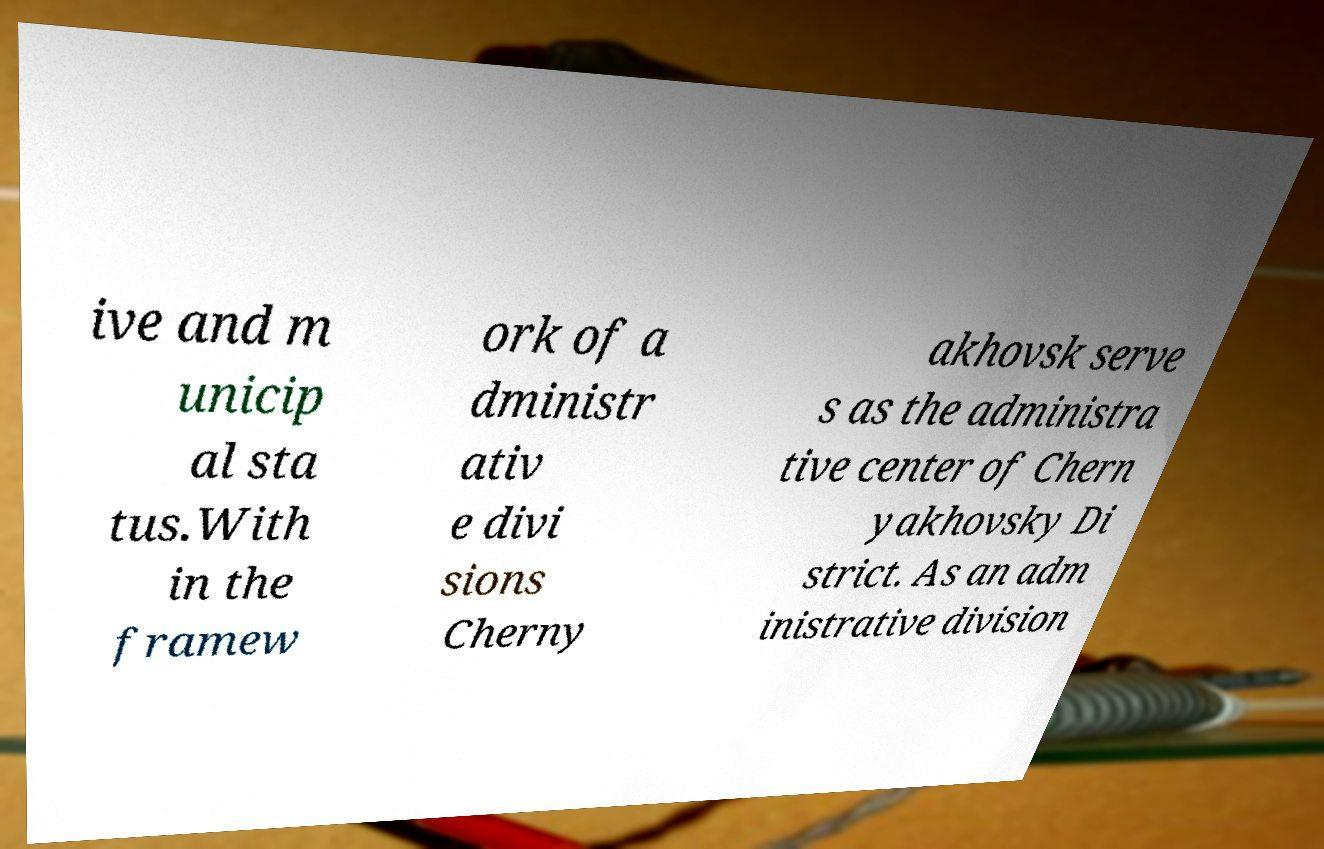Could you extract and type out the text from this image? ive and m unicip al sta tus.With in the framew ork of a dministr ativ e divi sions Cherny akhovsk serve s as the administra tive center of Chern yakhovsky Di strict. As an adm inistrative division 